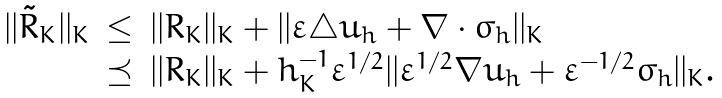<formula> <loc_0><loc_0><loc_500><loc_500>\begin{array} { l l l } | | \tilde { R } _ { K } | | _ { K } & \leq & | | R _ { K } | | _ { K } + | | \varepsilon \triangle u _ { h } + \nabla \cdot \sigma _ { h } | | _ { K } \\ & \preceq & | | R _ { K } | | _ { K } + h _ { K } ^ { - 1 } \varepsilon ^ { 1 / 2 } | | \varepsilon ^ { 1 / 2 } \nabla u _ { h } + \varepsilon ^ { - 1 / 2 } \sigma _ { h } | | _ { K } . \end{array}</formula> 